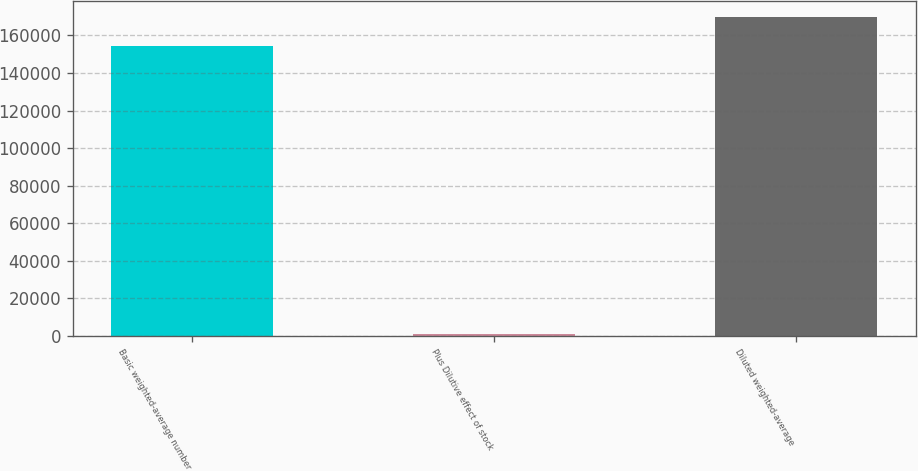<chart> <loc_0><loc_0><loc_500><loc_500><bar_chart><fcel>Basic weighted-average number<fcel>Plus Dilutive effect of stock<fcel>Diluted weighted-average<nl><fcel>154652<fcel>876<fcel>170117<nl></chart> 